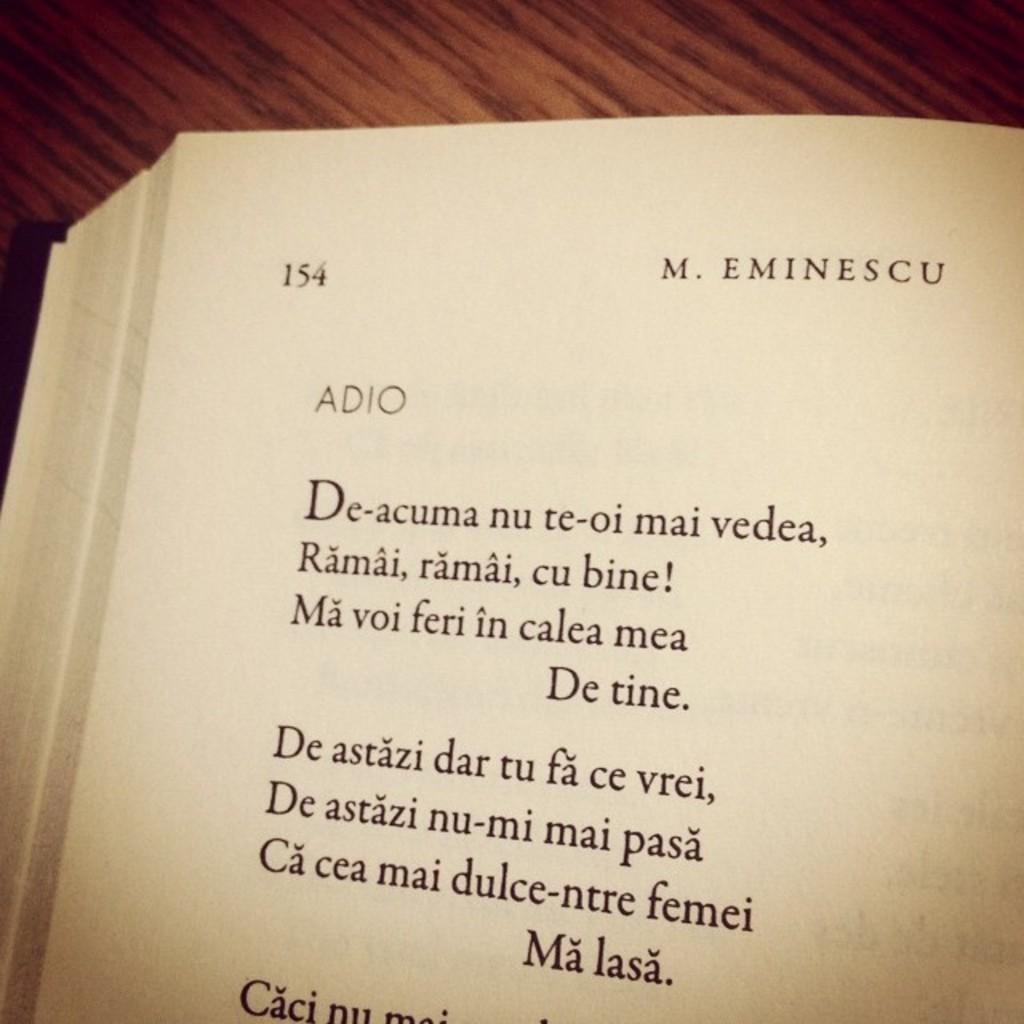Who is the author of the book?
Make the answer very short. M. eminescu. In what page are they reading?
Provide a succinct answer. 154. 